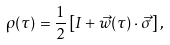<formula> <loc_0><loc_0><loc_500><loc_500>\rho ( \tau ) = \frac { 1 } { 2 } \left [ I + \vec { w } ( \tau ) \cdot \vec { \sigma } \right ] ,</formula> 